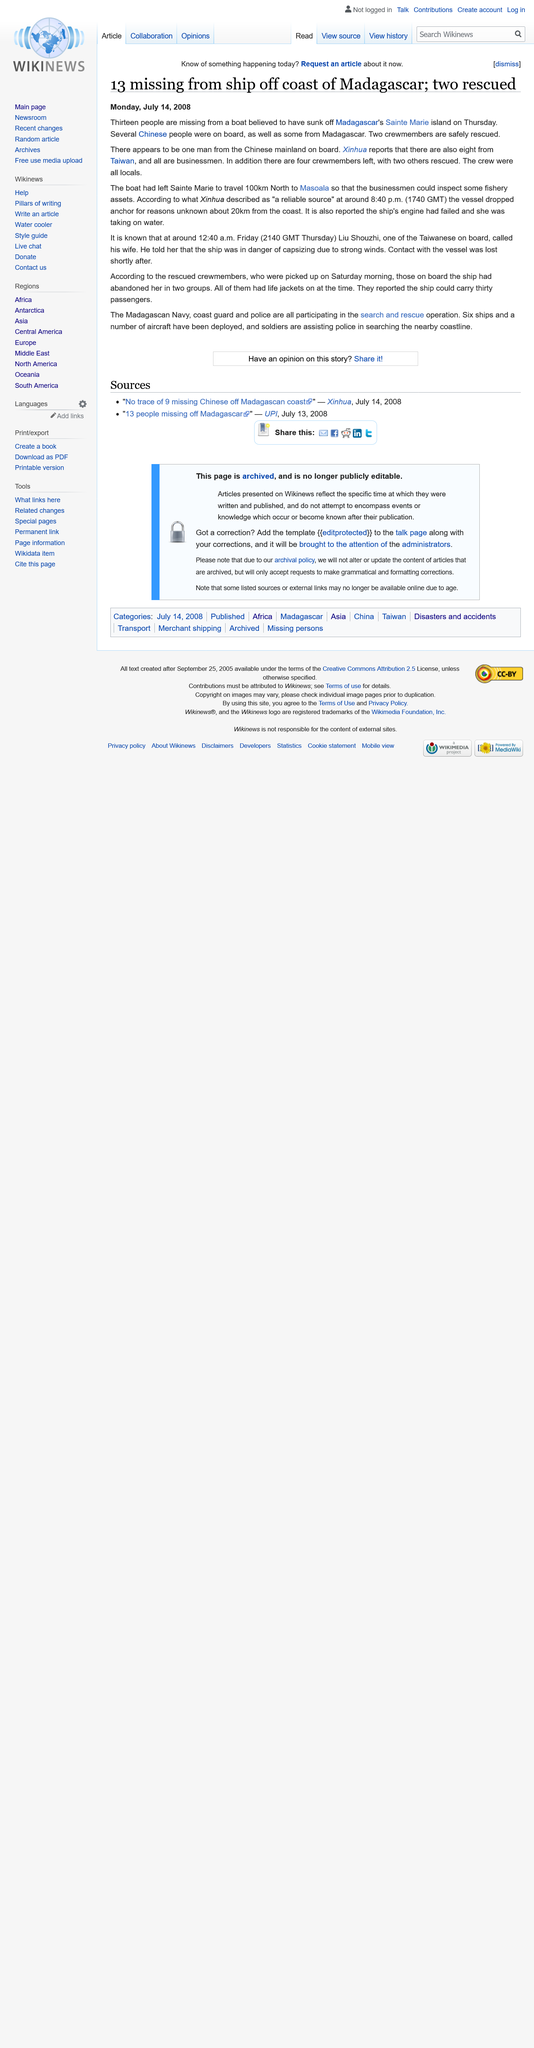Draw attention to some important aspects in this diagram. I am approximately 20 kilometers from the coast," declares the speaker. The businessman was on a ship, traveling on a journey to inspect the fishery assets, and this was all part of his business. A total of 13 people are still unaccounted for after a boat sank off the coast of Sainte Marie Island in Madagascar. 